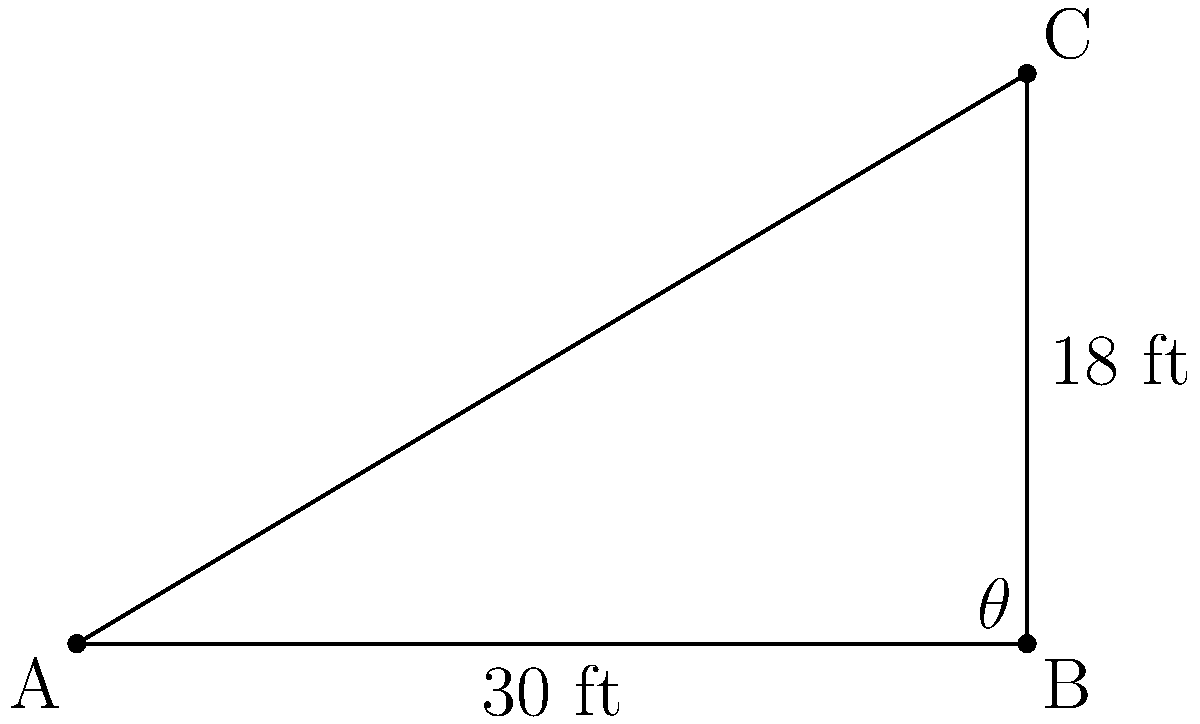As a food distributor, you need to stack crates efficiently in a warehouse. To maximize space, you want to calculate the angle of elevation for a ramp used to stack crates. If the warehouse has a ceiling height of 18 feet and the ramp needs to extend 30 feet from the wall, what is the angle of elevation ($\theta$) of the ramp? To solve this problem, we can use trigonometry. We have a right triangle where:

1. The adjacent side (base of the ramp) is 30 feet
2. The opposite side (height of the stack) is 18 feet
3. We need to find the angle $\theta$

We can use the tangent function to solve for $\theta$:

$\tan(\theta) = \frac{\text{opposite}}{\text{adjacent}}$

$\tan(\theta) = \frac{18}{30}$

$\tan(\theta) = 0.6$

To find $\theta$, we need to use the inverse tangent (arctan or $\tan^{-1}$):

$\theta = \tan^{-1}(0.6)$

Using a calculator or trigonometric tables:

$\theta \approx 30.96^\circ$

Rounding to the nearest degree:

$\theta \approx 31^\circ$
Answer: $31^\circ$ 